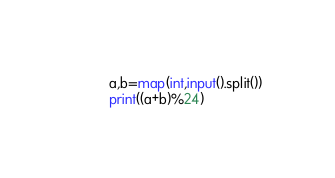<code> <loc_0><loc_0><loc_500><loc_500><_Python_>a,b=map(int,input().split())
print((a+b)%24)</code> 